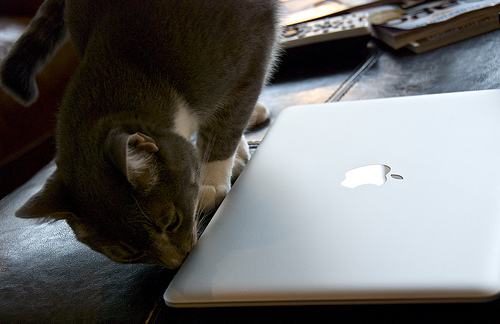How many black laptops are there? 0 